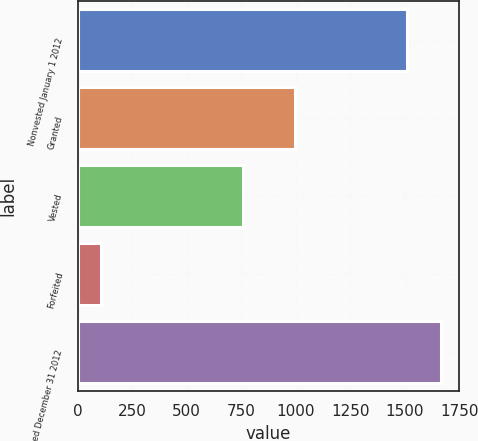Convert chart. <chart><loc_0><loc_0><loc_500><loc_500><bar_chart><fcel>Nonvested January 1 2012<fcel>Granted<fcel>Vested<fcel>Forfeited<fcel>Nonvested December 31 2012<nl><fcel>1513<fcel>996<fcel>756<fcel>105<fcel>1667.3<nl></chart> 